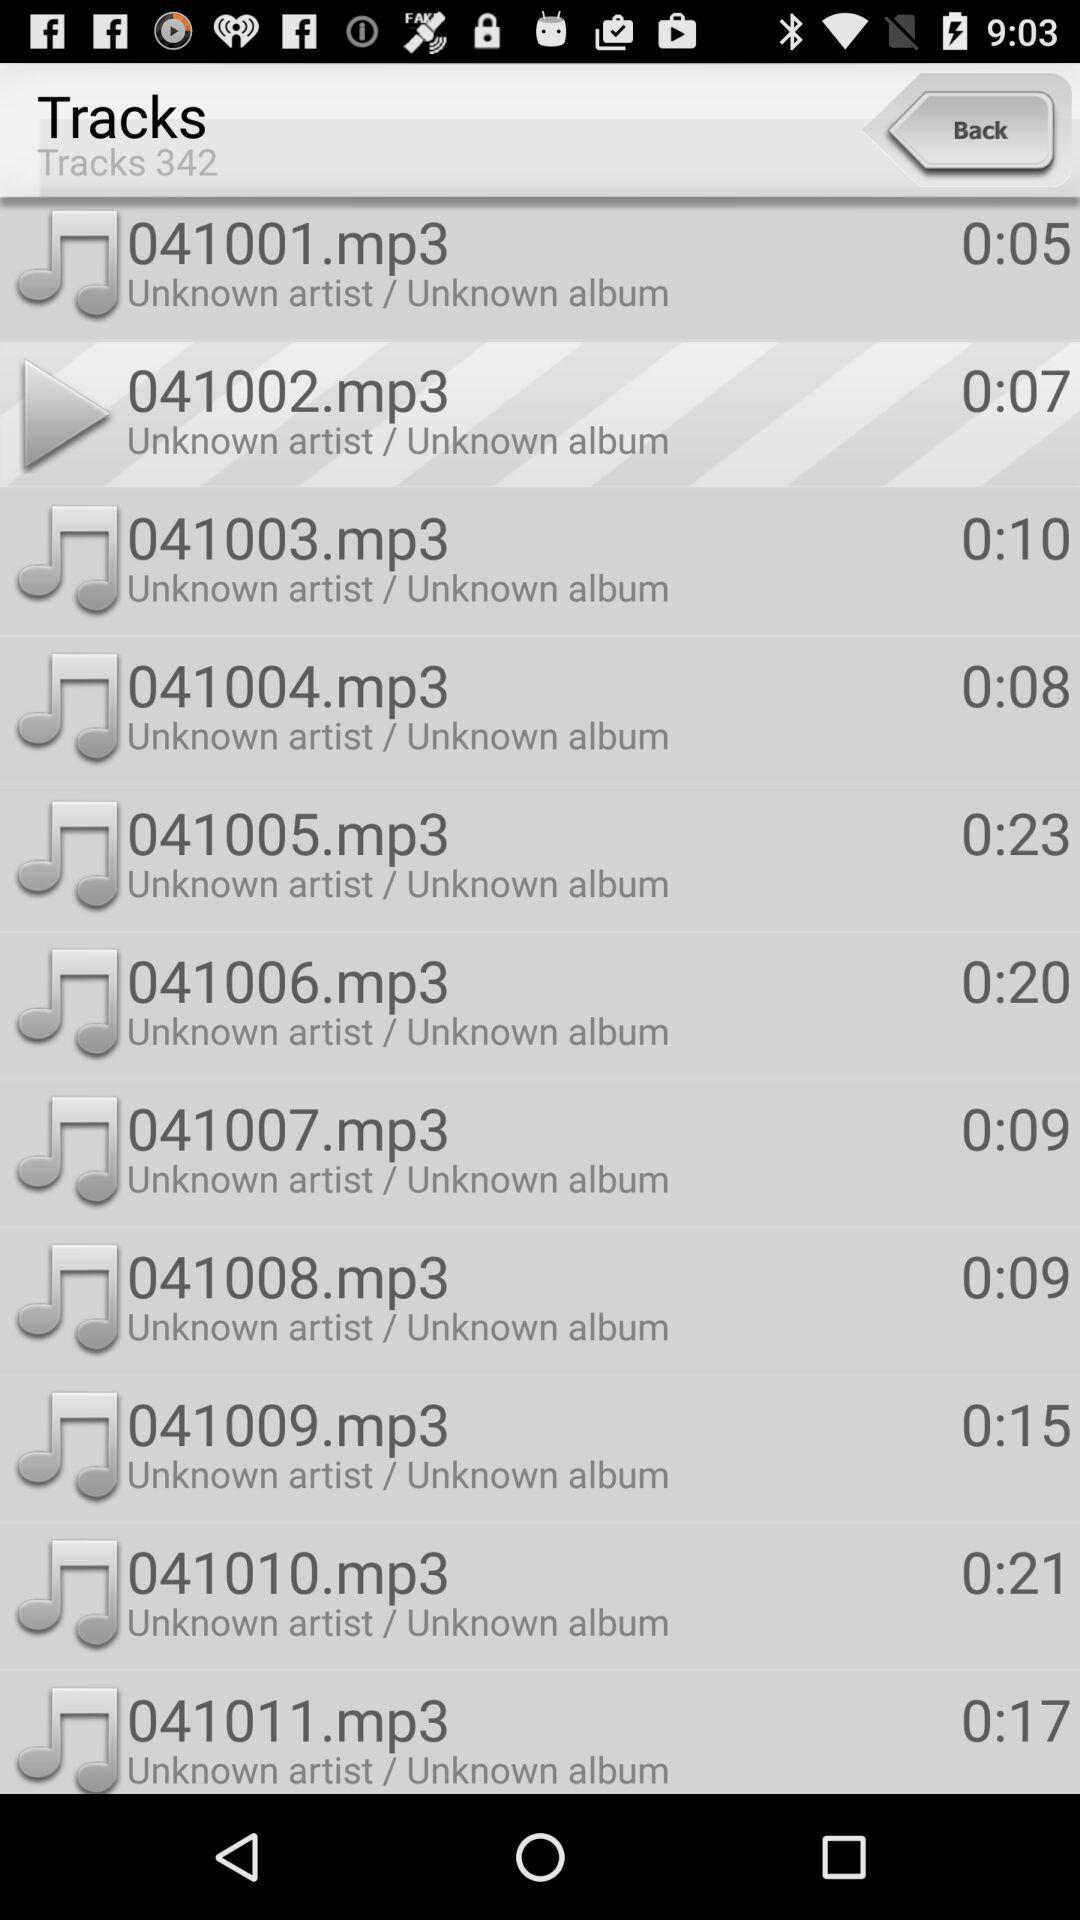What is the duration of track "041008.mp3"? The duration of track "041008.mp3" is 9 seconds. 